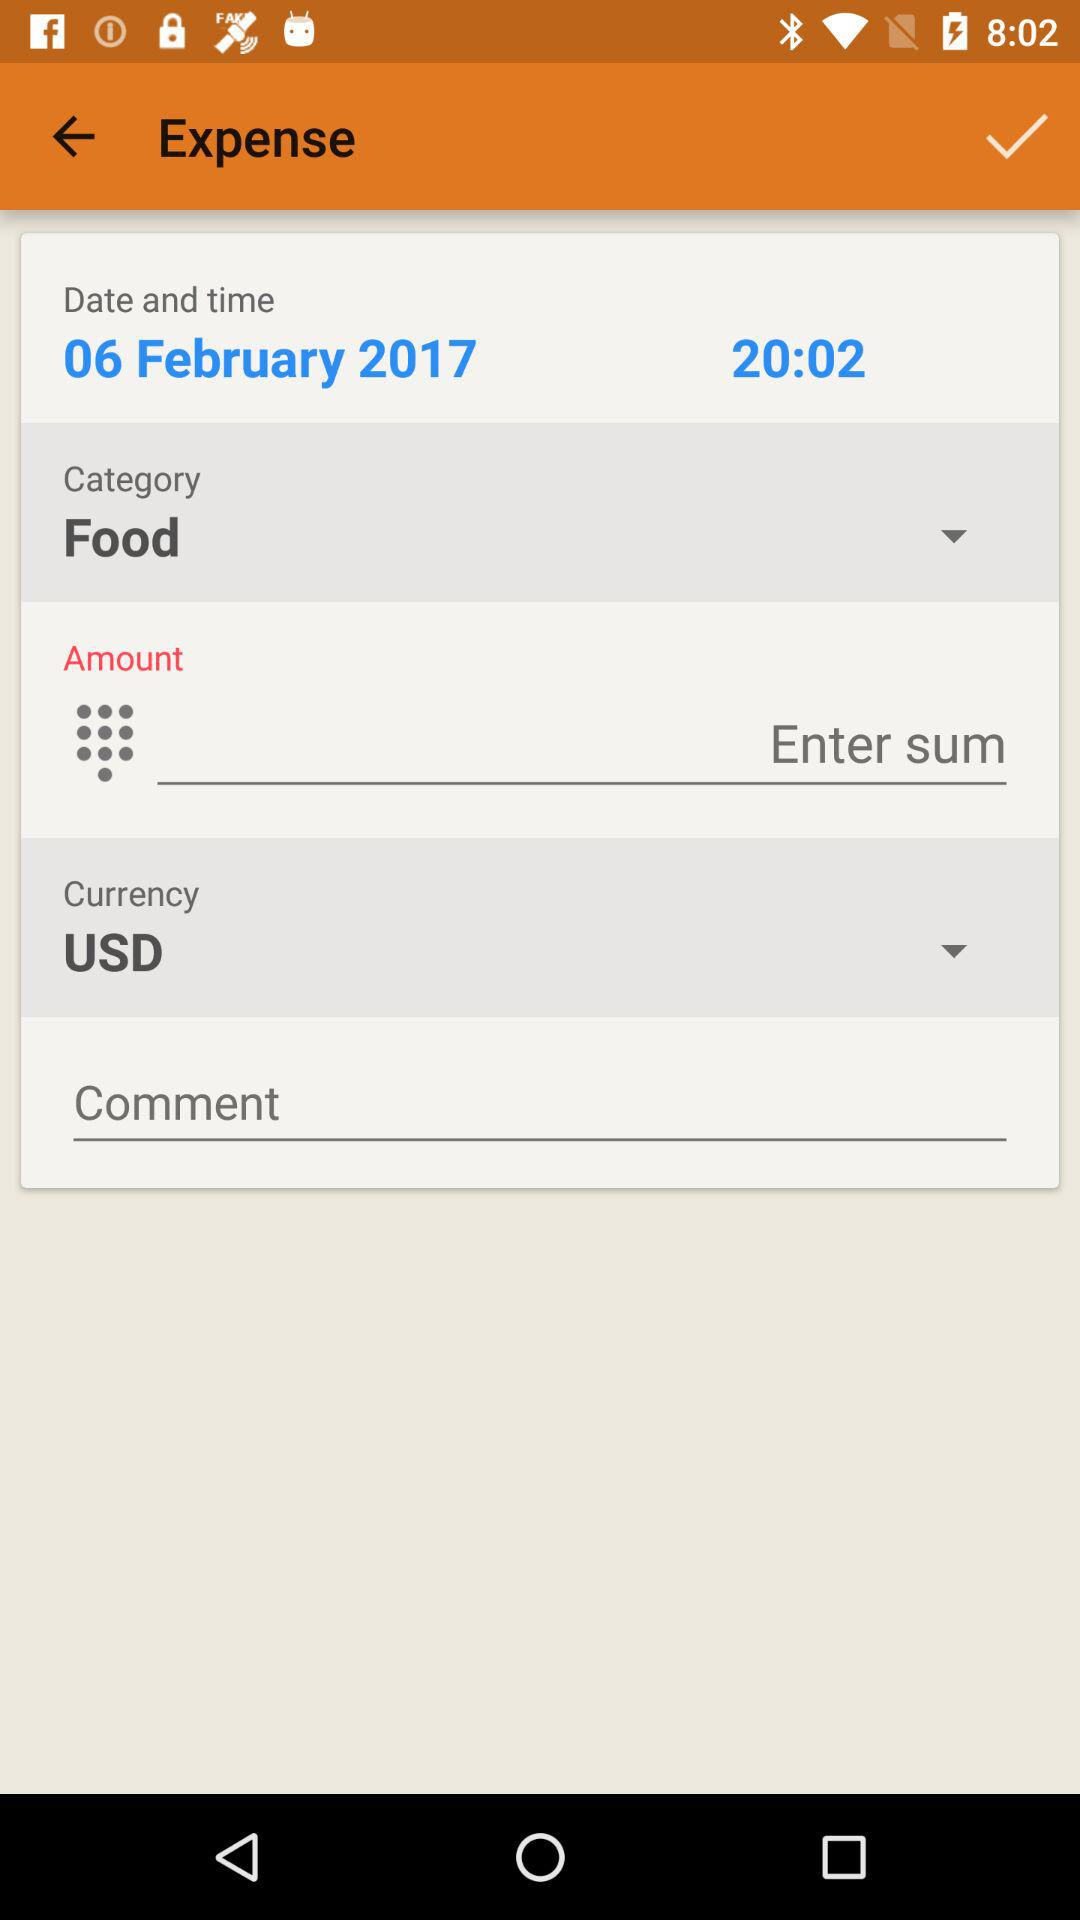What is the currency of the expense?
Answer the question using a single word or phrase. USD 